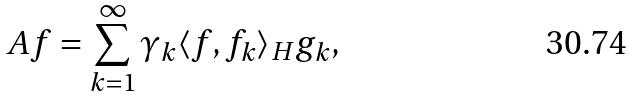<formula> <loc_0><loc_0><loc_500><loc_500>A f = \sum _ { k = 1 } ^ { \infty } \gamma _ { k } \langle f , f _ { k } \rangle _ { H } g _ { k } ,</formula> 